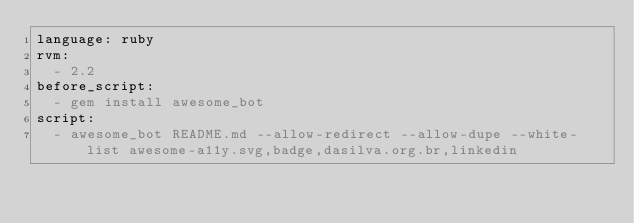<code> <loc_0><loc_0><loc_500><loc_500><_YAML_>language: ruby
rvm:
  - 2.2
before_script:
  - gem install awesome_bot
script:
  - awesome_bot README.md --allow-redirect --allow-dupe --white-list awesome-a11y.svg,badge,dasilva.org.br,linkedin
</code> 